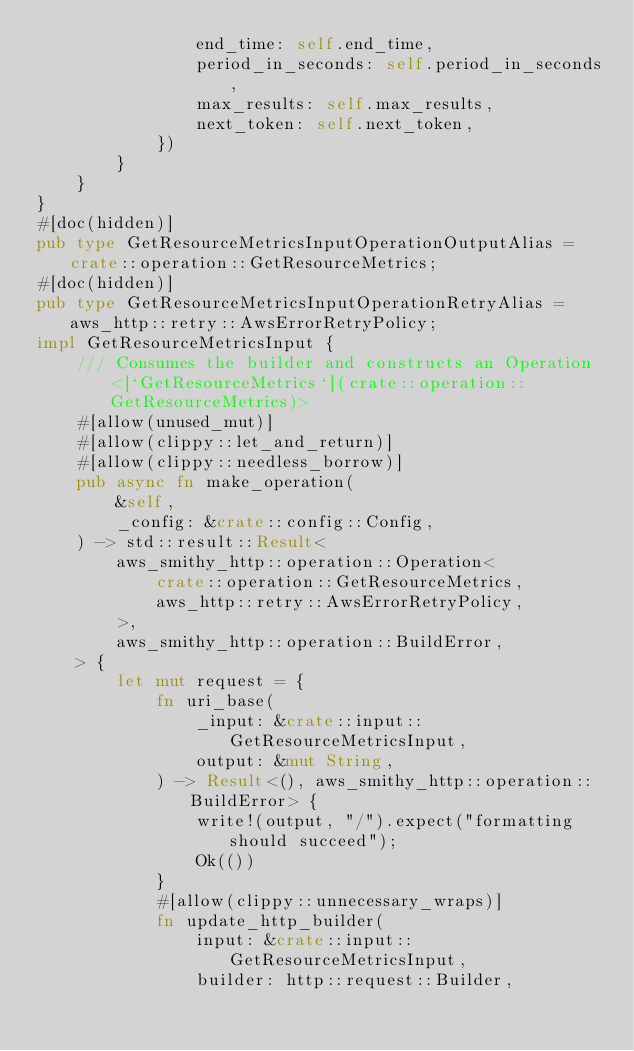<code> <loc_0><loc_0><loc_500><loc_500><_Rust_>                end_time: self.end_time,
                period_in_seconds: self.period_in_seconds,
                max_results: self.max_results,
                next_token: self.next_token,
            })
        }
    }
}
#[doc(hidden)]
pub type GetResourceMetricsInputOperationOutputAlias = crate::operation::GetResourceMetrics;
#[doc(hidden)]
pub type GetResourceMetricsInputOperationRetryAlias = aws_http::retry::AwsErrorRetryPolicy;
impl GetResourceMetricsInput {
    /// Consumes the builder and constructs an Operation<[`GetResourceMetrics`](crate::operation::GetResourceMetrics)>
    #[allow(unused_mut)]
    #[allow(clippy::let_and_return)]
    #[allow(clippy::needless_borrow)]
    pub async fn make_operation(
        &self,
        _config: &crate::config::Config,
    ) -> std::result::Result<
        aws_smithy_http::operation::Operation<
            crate::operation::GetResourceMetrics,
            aws_http::retry::AwsErrorRetryPolicy,
        >,
        aws_smithy_http::operation::BuildError,
    > {
        let mut request = {
            fn uri_base(
                _input: &crate::input::GetResourceMetricsInput,
                output: &mut String,
            ) -> Result<(), aws_smithy_http::operation::BuildError> {
                write!(output, "/").expect("formatting should succeed");
                Ok(())
            }
            #[allow(clippy::unnecessary_wraps)]
            fn update_http_builder(
                input: &crate::input::GetResourceMetricsInput,
                builder: http::request::Builder,</code> 